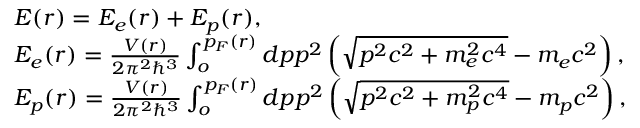<formula> <loc_0><loc_0><loc_500><loc_500>\begin{array} { l } { E ( r ) = E _ { e } ( r ) + E _ { p } ( r ) , } \\ { E _ { e } ( r ) = \frac { V ( r ) } { 2 \pi ^ { 2 } \hbar { ^ } { 3 } } \int _ { o } ^ { p _ { F } ( r ) } d p p ^ { 2 } \left ( \sqrt { p ^ { 2 } c ^ { 2 } + m _ { e } ^ { 2 } c ^ { 4 } } - m _ { e } c ^ { 2 } \right ) , } \\ { E _ { p } ( r ) = \frac { V ( r ) } { 2 \pi ^ { 2 } \hbar { ^ } { 3 } } \int _ { o } ^ { p _ { F } ( r ) } d p p ^ { 2 } \left ( \sqrt { p ^ { 2 } c ^ { 2 } + m _ { p } ^ { 2 } c ^ { 4 } } - m _ { p } c ^ { 2 } \right ) , } \end{array}</formula> 